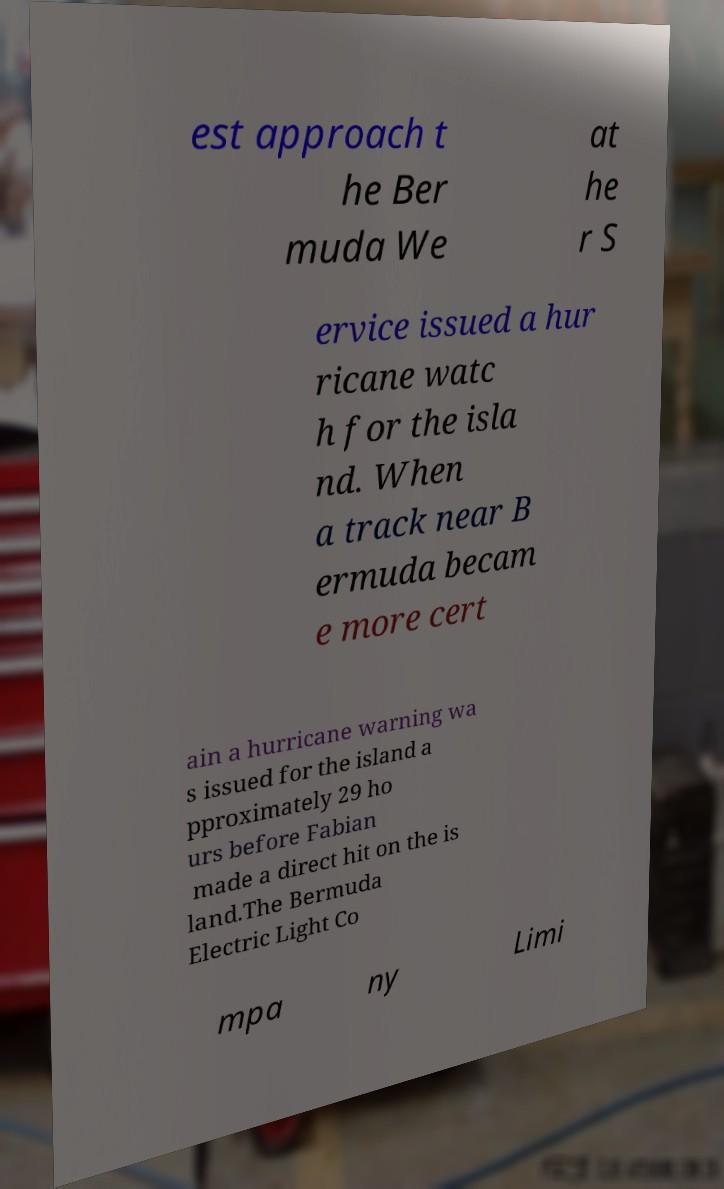Can you read and provide the text displayed in the image?This photo seems to have some interesting text. Can you extract and type it out for me? est approach t he Ber muda We at he r S ervice issued a hur ricane watc h for the isla nd. When a track near B ermuda becam e more cert ain a hurricane warning wa s issued for the island a pproximately 29 ho urs before Fabian made a direct hit on the is land.The Bermuda Electric Light Co mpa ny Limi 